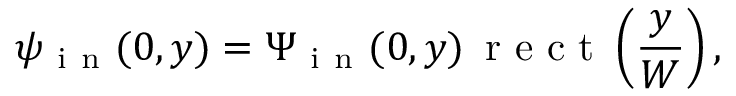Convert formula to latex. <formula><loc_0><loc_0><loc_500><loc_500>\psi _ { i n } ( 0 , y ) = \Psi _ { i n } ( 0 , y ) \, r e c t \left ( \frac { y } { W } \right ) ,</formula> 